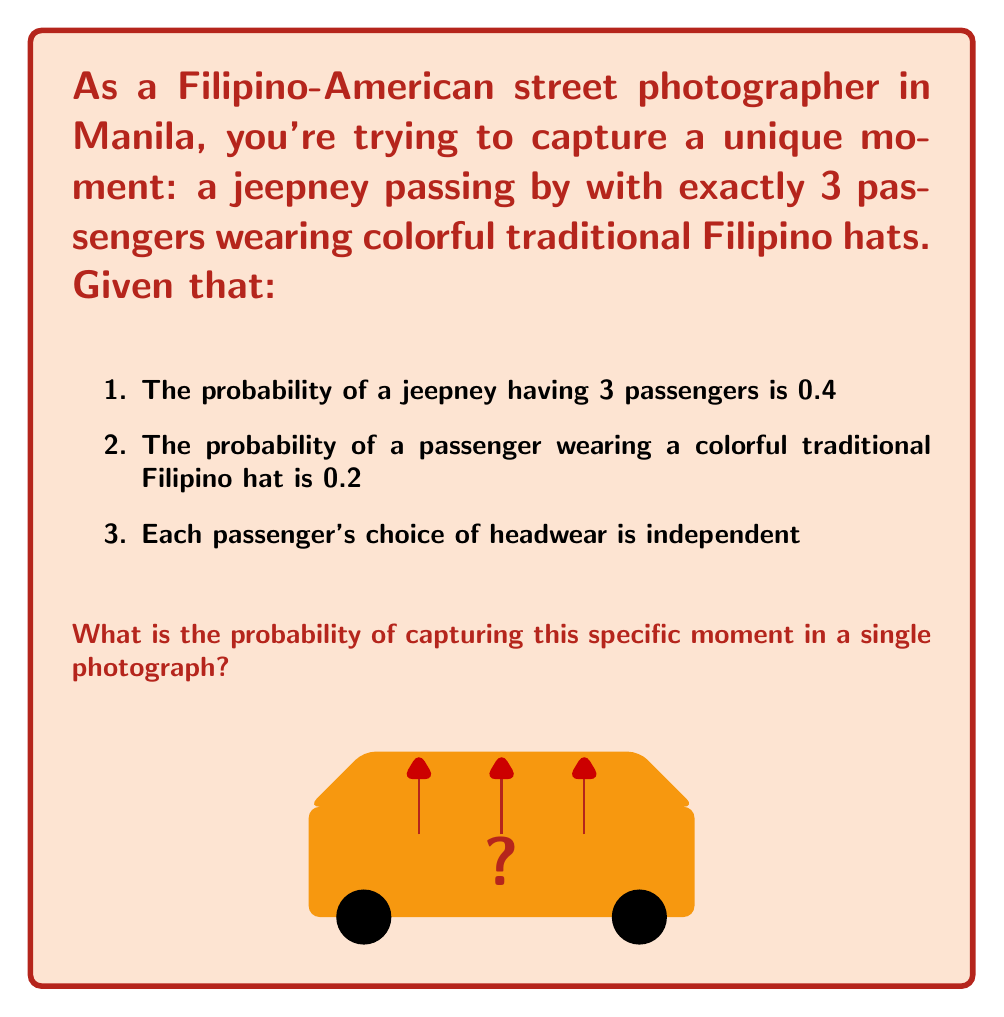Show me your answer to this math problem. To solve this problem, we need to use the multiplication rule of probability for independent events. Let's break it down step-by-step:

1) First, we need the probability of a jeepney having exactly 3 passengers. This is given as 0.4.

2) Next, we need the probability of all 3 passengers wearing colorful traditional Filipino hats. Since each passenger's choice is independent, we can multiply the individual probabilities:

   $P(\text{3 passengers with hats}) = 0.2 \times 0.2 \times 0.2 = 0.2^3 = 0.008$

3) Now, we need to combine these probabilities. Since we need both events to occur simultaneously (3 passengers AND all wearing hats), we multiply these probabilities:

   $P(\text{3 passengers AND all wearing hats}) = 0.4 \times 0.008 = 0.0032$

4) To express this as a percentage:

   $0.0032 \times 100\% = 0.32\%$

Thus, the probability of capturing this specific moment in a single photograph is 0.0032 or 0.32%.
Answer: $0.0032$ or $0.32\%$ 